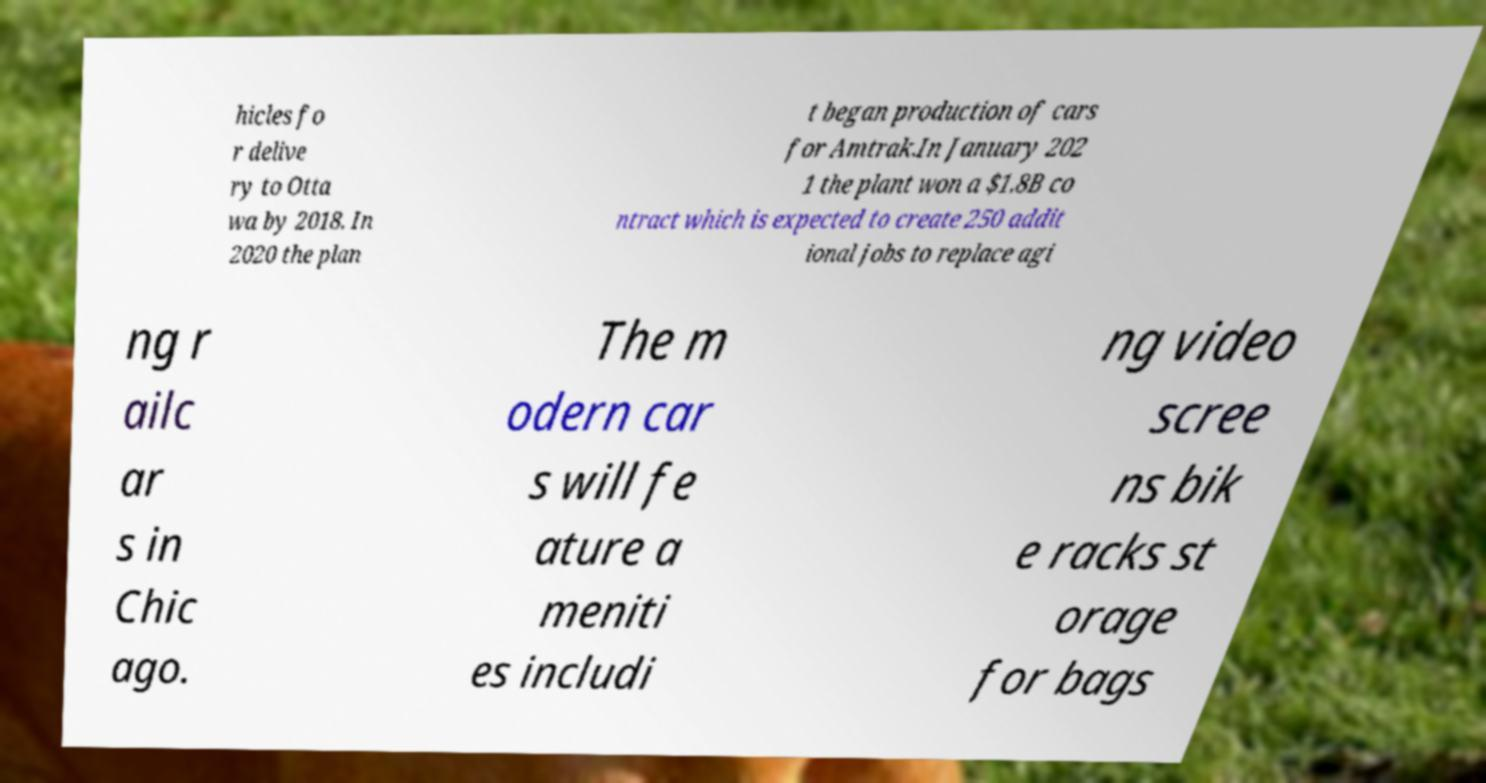What messages or text are displayed in this image? I need them in a readable, typed format. hicles fo r delive ry to Otta wa by 2018. In 2020 the plan t began production of cars for Amtrak.In January 202 1 the plant won a $1.8B co ntract which is expected to create 250 addit ional jobs to replace agi ng r ailc ar s in Chic ago. The m odern car s will fe ature a meniti es includi ng video scree ns bik e racks st orage for bags 